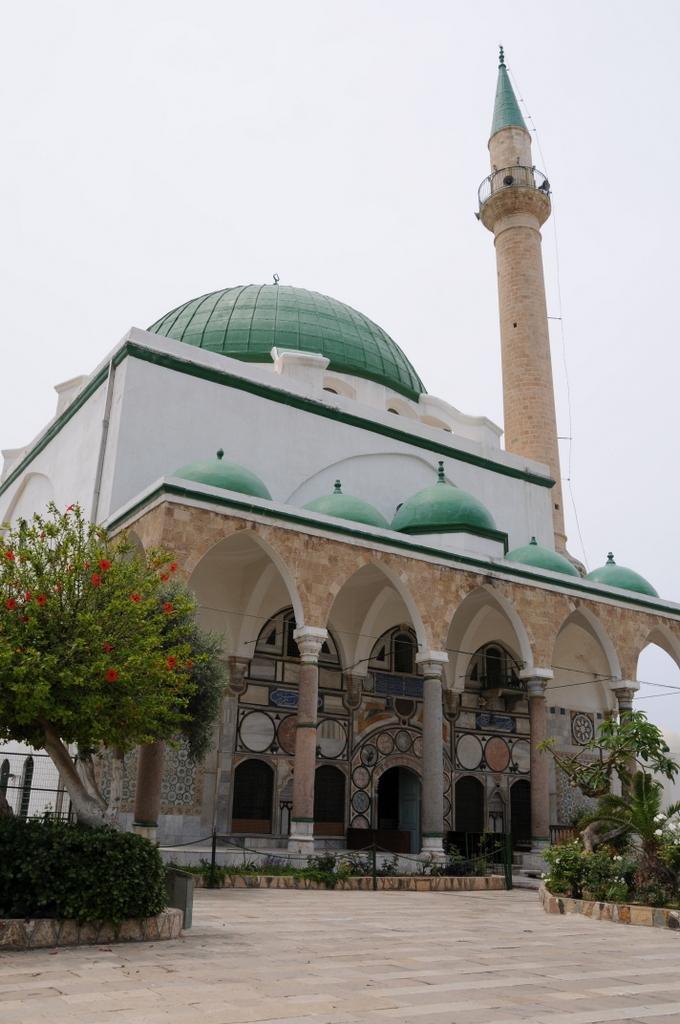How would you summarize this image in a sentence or two? In this image we can see a mosque. There is a tree at the left side of the image. There are many plants in the image. We can see the sky in the image. There is a walkway in the image. 